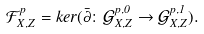Convert formula to latex. <formula><loc_0><loc_0><loc_500><loc_500>\mathcal { F } _ { X , Z } ^ { p } = k e r ( \bar { \partial } \colon \mathcal { G } _ { X , Z } ^ { p , 0 } \rightarrow \mathcal { G } _ { X , Z } ^ { p , 1 } ) .</formula> 